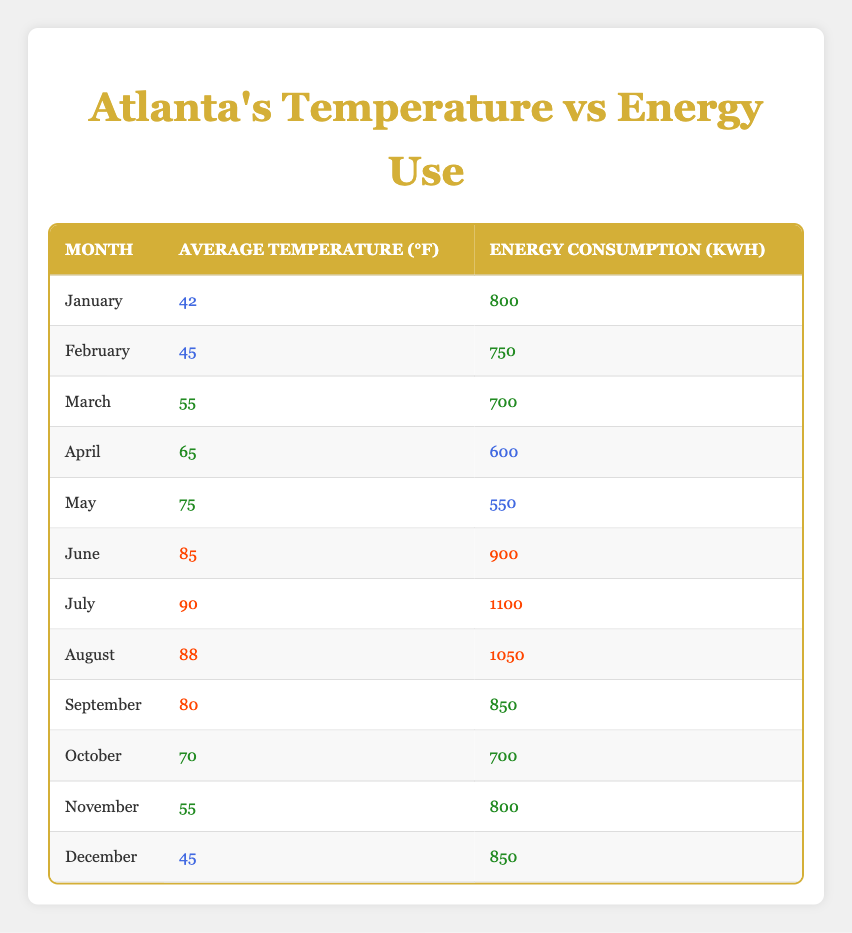What is the average temperature in July? July has an average temperature of 90°F, which can be directly found in the table under the respective month.
Answer: 90°F Which month has the highest energy consumption? The highest energy consumption of 1100 kWh corresponds to July, as indicated in the table.
Answer: July What is the energy consumption in May? In May, the energy consumption is listed as 550 kWh in the table.
Answer: 550 kWh Is the energy consumption higher in December than in April? In December, the energy consumption is 850 kWh, while in April it is 600 kWh. Thus, December has higher energy consumption.
Answer: Yes What is the difference in energy consumption between June and August? In June, energy consumption is 900 kWh, and in August, it is 1050 kWh. The difference is calculated as 1050 - 900 = 150 kWh.
Answer: 150 kWh What is the average energy consumption over the months? The energy consumption values are: 800, 750, 700, 600, 550, 900, 1100, 1050, 850, 700, 800, 850. The total is 8500 kWh, and there are 12 months, so the average is 8500 / 12 = 708.33 kWh.
Answer: 708.33 kWh Which month has the lowest average temperature? January has the lowest average temperature of 42°F, as seen directly in the table.
Answer: January Are the months with high average temperatures always associated with high energy consumption? In July and August, the average temperatures are 90°F and 88°F, respectively, and the energy consumption is the highest in July (1100 kWh) and also high in August (1050 kWh). However, in June, the temperature is 85°F but energy consumption is only 900 kWh. This shows a tendency, but it's not absolute.
Answer: No 